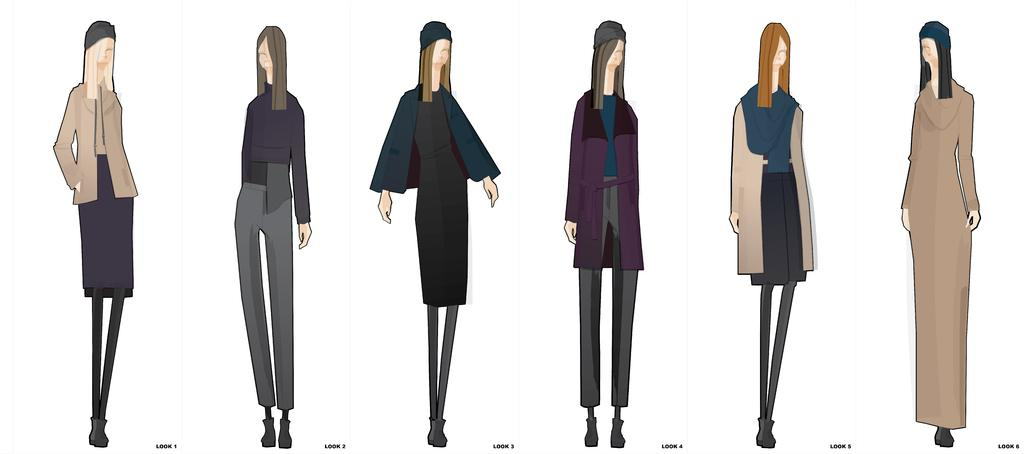What type of image is being depicted? The image is an animation. How many ladies are present in the image? There are six ladies in the image. Can you describe the appearance of the ladies in the image? Each lady has a different attire. What type of game are the ladies playing in the image? There is no game being played in the image; it only depicts the ladies with different attires. What impulse might have led the ladies to choose their specific attires? The image does not provide any information about the ladies' motivations or impulses for choosing their attires. --- 